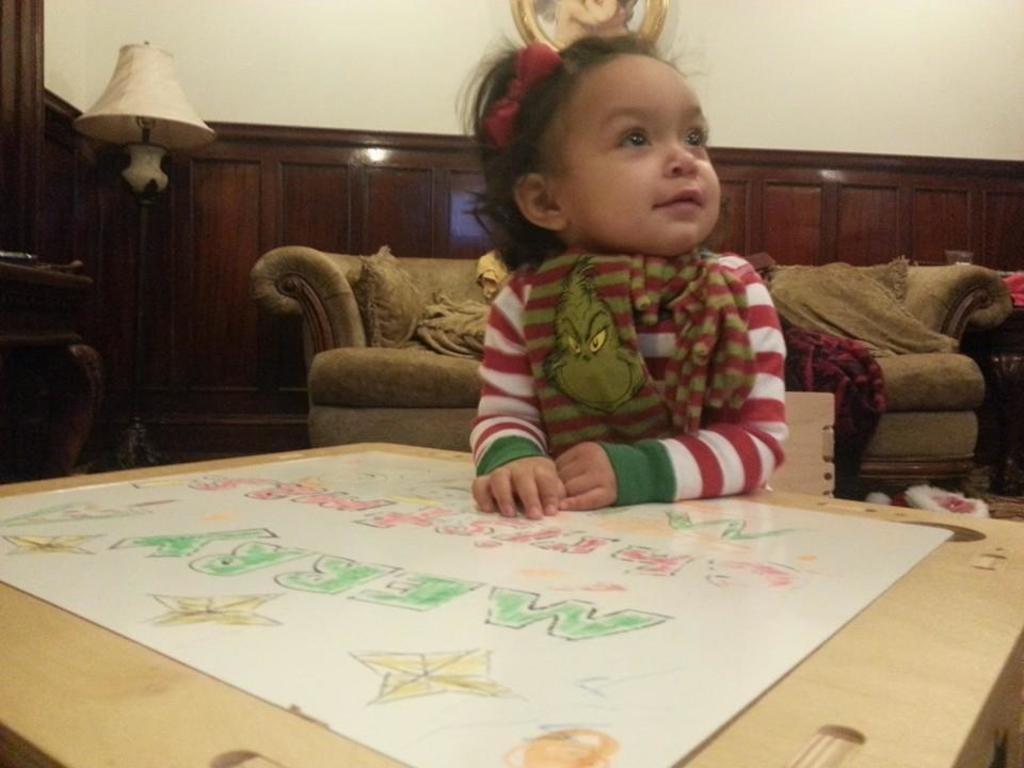How would you summarize this image in a sentence or two? In the image we can see there is a girl who is sitting and in front of her there is a cardboard box on which there is a sheet of paper. 